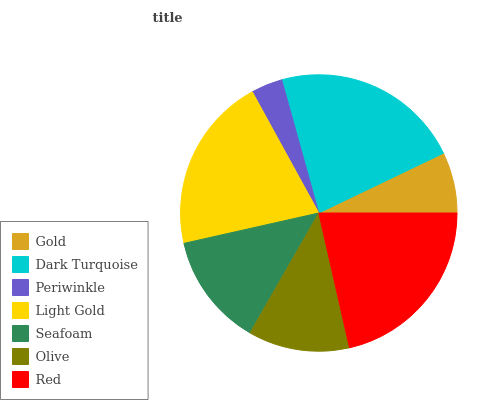Is Periwinkle the minimum?
Answer yes or no. Yes. Is Dark Turquoise the maximum?
Answer yes or no. Yes. Is Dark Turquoise the minimum?
Answer yes or no. No. Is Periwinkle the maximum?
Answer yes or no. No. Is Dark Turquoise greater than Periwinkle?
Answer yes or no. Yes. Is Periwinkle less than Dark Turquoise?
Answer yes or no. Yes. Is Periwinkle greater than Dark Turquoise?
Answer yes or no. No. Is Dark Turquoise less than Periwinkle?
Answer yes or no. No. Is Seafoam the high median?
Answer yes or no. Yes. Is Seafoam the low median?
Answer yes or no. Yes. Is Dark Turquoise the high median?
Answer yes or no. No. Is Light Gold the low median?
Answer yes or no. No. 